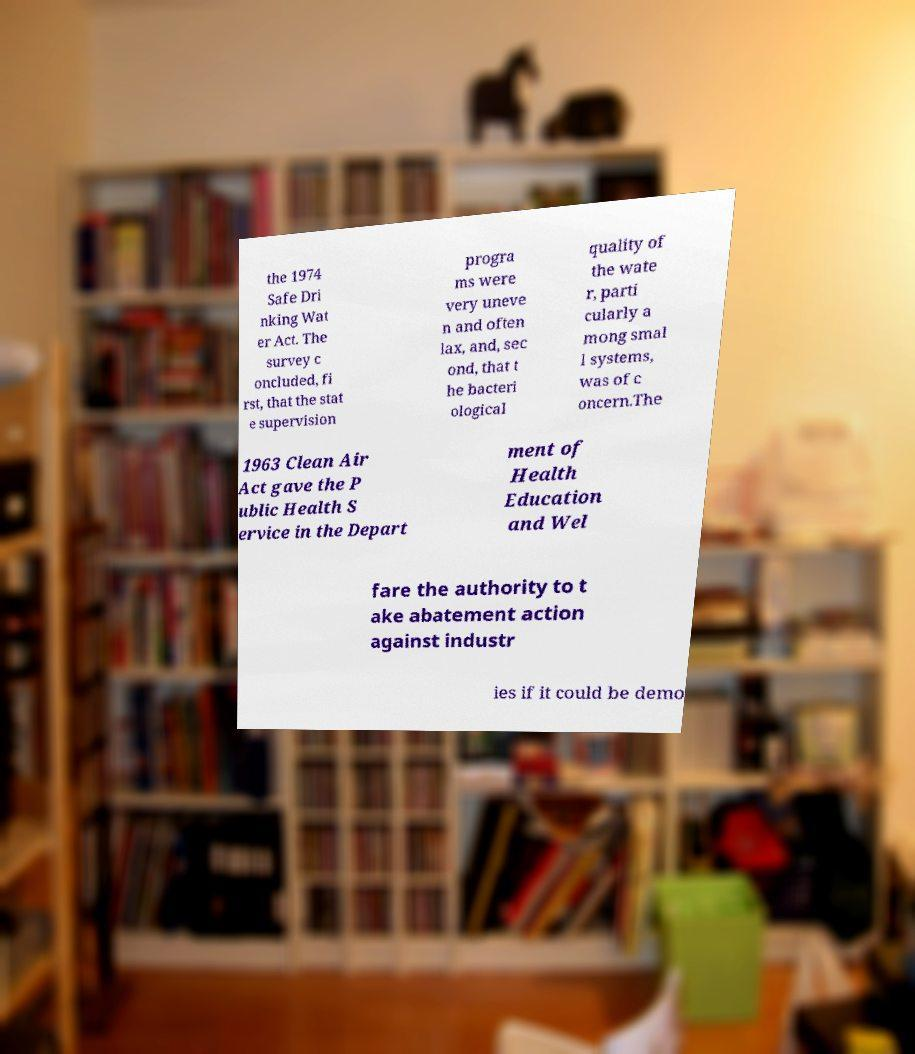There's text embedded in this image that I need extracted. Can you transcribe it verbatim? the 1974 Safe Dri nking Wat er Act. The survey c oncluded, fi rst, that the stat e supervision progra ms were very uneve n and often lax, and, sec ond, that t he bacteri ological quality of the wate r, parti cularly a mong smal l systems, was of c oncern.The 1963 Clean Air Act gave the P ublic Health S ervice in the Depart ment of Health Education and Wel fare the authority to t ake abatement action against industr ies if it could be demo 